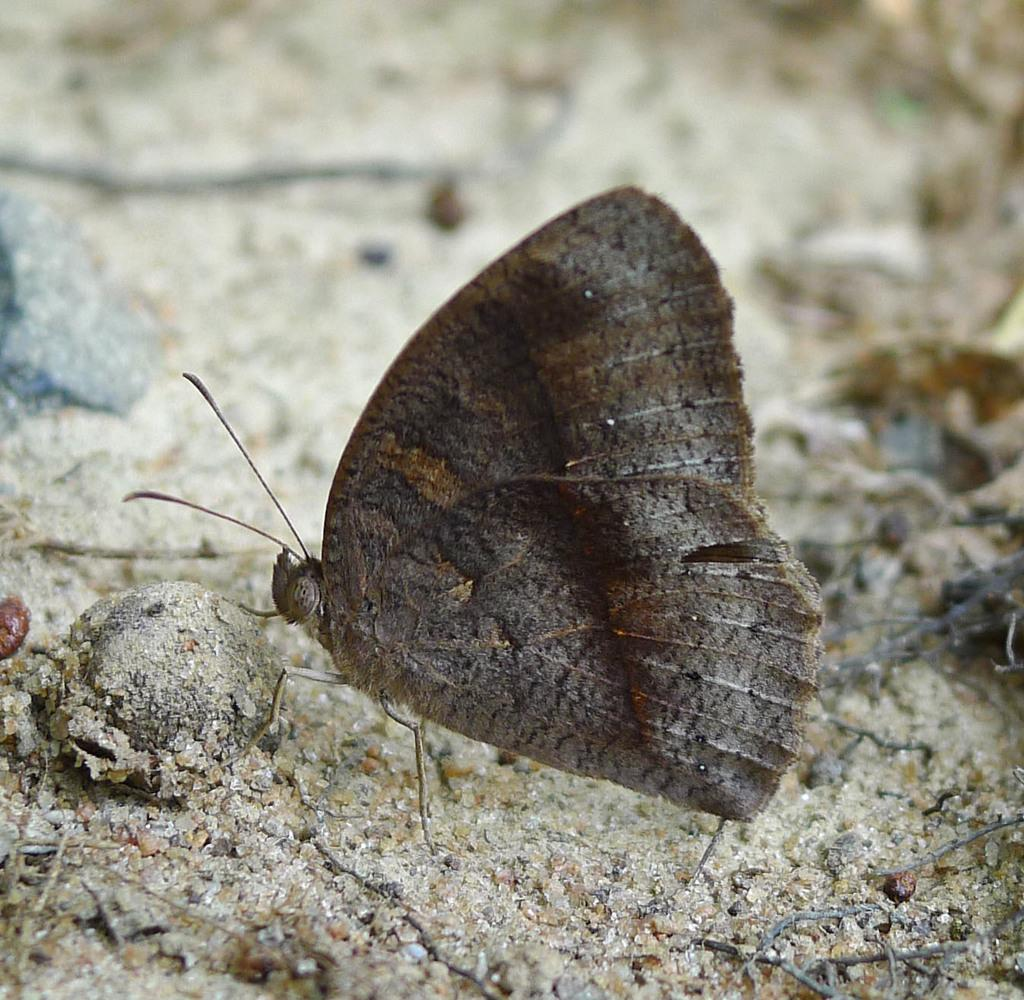What is on the ground in the image? There is a butterfly on the ground in the image. Can you describe the background of the image? The background of the image is blurred. What type of corn is being sold in the image? There is no corn present in the image; it features a butterfly on the ground with a blurred background. 